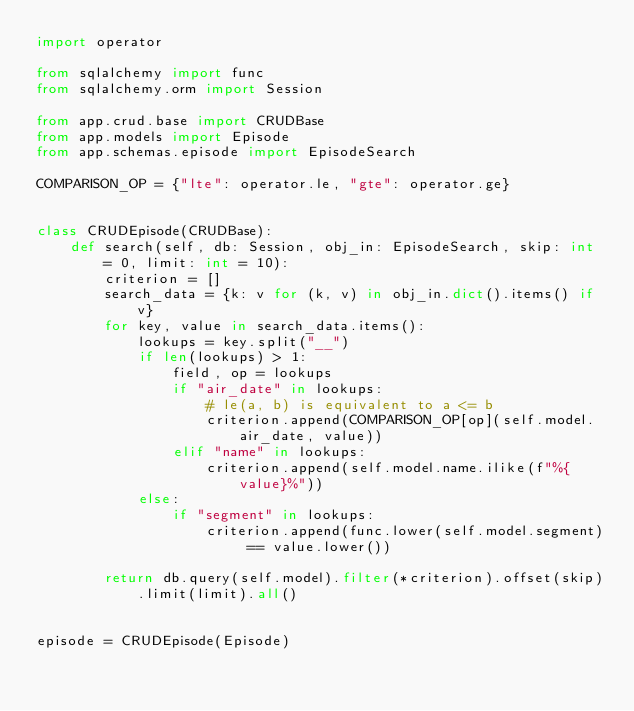Convert code to text. <code><loc_0><loc_0><loc_500><loc_500><_Python_>import operator

from sqlalchemy import func
from sqlalchemy.orm import Session

from app.crud.base import CRUDBase
from app.models import Episode
from app.schemas.episode import EpisodeSearch

COMPARISON_OP = {"lte": operator.le, "gte": operator.ge}


class CRUDEpisode(CRUDBase):
    def search(self, db: Session, obj_in: EpisodeSearch, skip: int = 0, limit: int = 10):
        criterion = []
        search_data = {k: v for (k, v) in obj_in.dict().items() if v}
        for key, value in search_data.items():
            lookups = key.split("__")
            if len(lookups) > 1:
                field, op = lookups
                if "air_date" in lookups:
                    # le(a, b) is equivalent to a <= b
                    criterion.append(COMPARISON_OP[op](self.model.air_date, value))
                elif "name" in lookups:
                    criterion.append(self.model.name.ilike(f"%{value}%"))
            else:
                if "segment" in lookups:
                    criterion.append(func.lower(self.model.segment) == value.lower())

        return db.query(self.model).filter(*criterion).offset(skip).limit(limit).all()


episode = CRUDEpisode(Episode)
</code> 